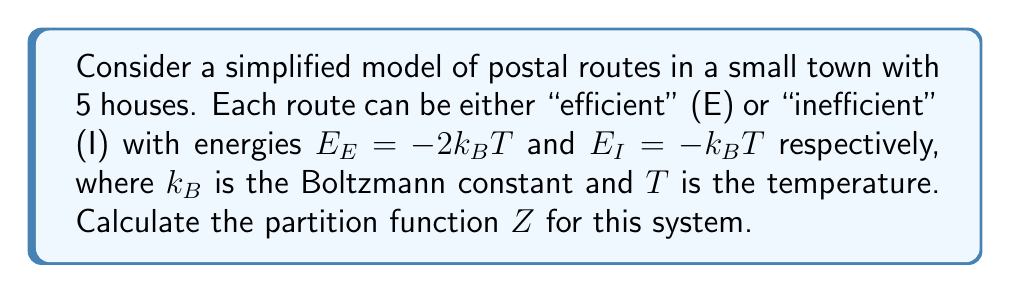Provide a solution to this math problem. Let's approach this step-by-step:

1) The partition function $Z$ is defined as the sum of all possible microstates:

   $$Z = \sum_i e^{-\beta E_i}$$

   where $\beta = \frac{1}{k_BT}$

2) In our case, each house can be in one of two states (E or I), and we have 5 houses. So, the total number of microstates is $2^5 = 32$.

3) Let's define $n_E$ as the number of efficient routes and $n_I$ as the number of inefficient routes. We know $n_E + n_I = 5$.

4) The energy of a particular microstate is:

   $$E = n_E E_E + n_I E_I = -2n_E k_BT - n_I k_BT = -(2n_E + n_I)k_BT$$

5) Therefore, for a given microstate:

   $$e^{-\beta E} = e^{(2n_E + n_I)} = e^{2n_E} \cdot e^{n_I}$$

6) We can use the binomial theorem to sum over all possible combinations:

   $$Z = \sum_{n_E=0}^5 \binom{5}{n_E} e^{2n_E} \cdot e^{5-n_E} = (e + e^2)^5$$

7) Simplifying:

   $$Z = (e + e^2)^5 = (e(1 + e))^5 = e^5 (1 + e)^5$$

This is our final expression for the partition function.
Answer: $Z = e^5 (1 + e)^5$ 